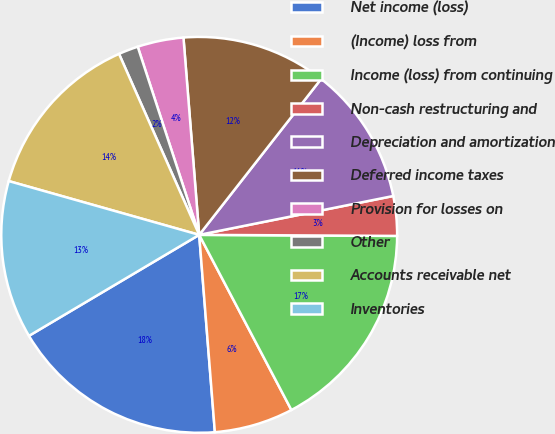<chart> <loc_0><loc_0><loc_500><loc_500><pie_chart><fcel>Net income (loss)<fcel>(Income) loss from<fcel>Income (loss) from continuing<fcel>Non-cash restructuring and<fcel>Depreciation and amortization<fcel>Deferred income taxes<fcel>Provision for losses on<fcel>Other<fcel>Accounts receivable net<fcel>Inventories<nl><fcel>17.74%<fcel>6.45%<fcel>17.2%<fcel>3.23%<fcel>11.29%<fcel>11.83%<fcel>3.76%<fcel>1.61%<fcel>13.98%<fcel>12.9%<nl></chart> 